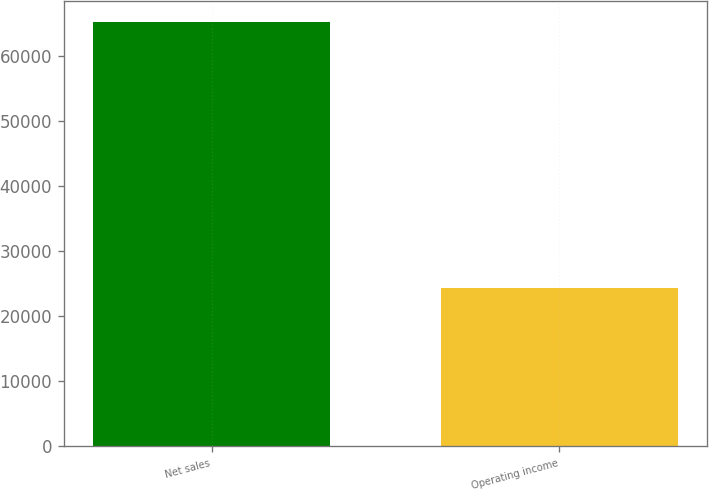Convert chart. <chart><loc_0><loc_0><loc_500><loc_500><bar_chart><fcel>Net sales<fcel>Operating income<nl><fcel>65232<fcel>24316<nl></chart> 